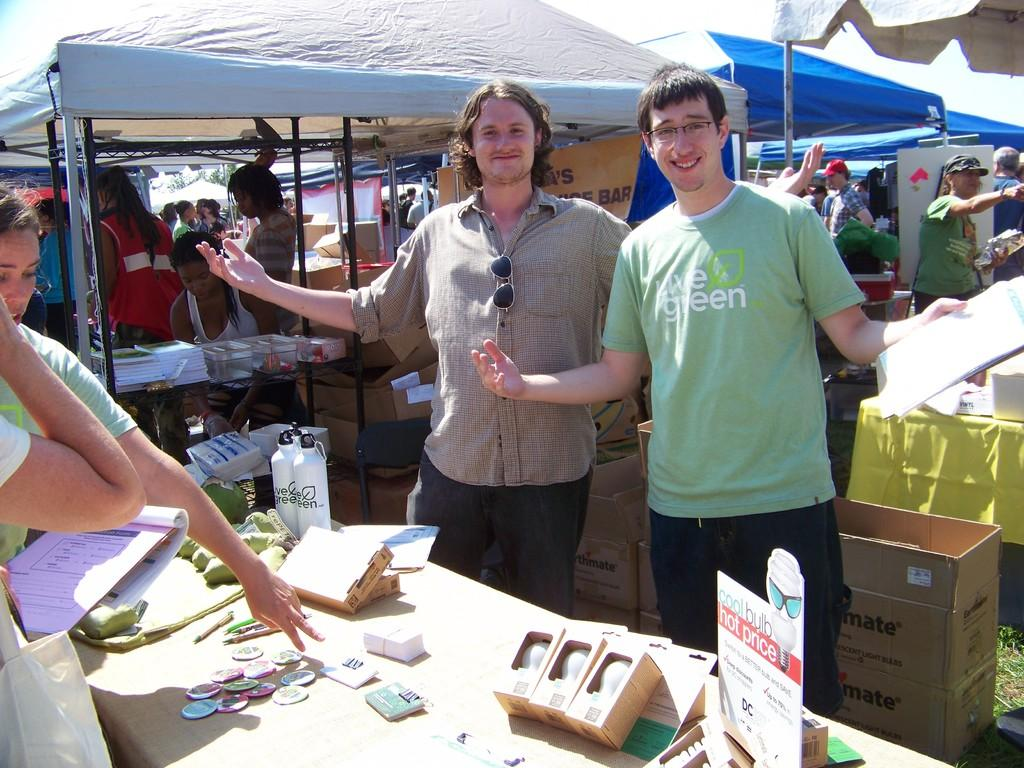How many people are visible in the image? There are persons in the image, and more persons can be seen in the background. What is present on the table in the image? There is a table in the image, and on it, there are badges, boxes, bottles, and a board. What can be seen in the background of the image? In the background, there are tents, a banner, additional boxes, and more persons. Is there any quicksand visible in the image? No, there is no quicksand present in the image. Can you see a hen in the image? No, there is no hen present in the image. 